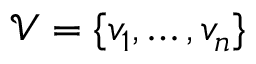<formula> <loc_0><loc_0><loc_500><loc_500>\mathcal { V } = \{ v _ { 1 } , \dots , v _ { n } \}</formula> 